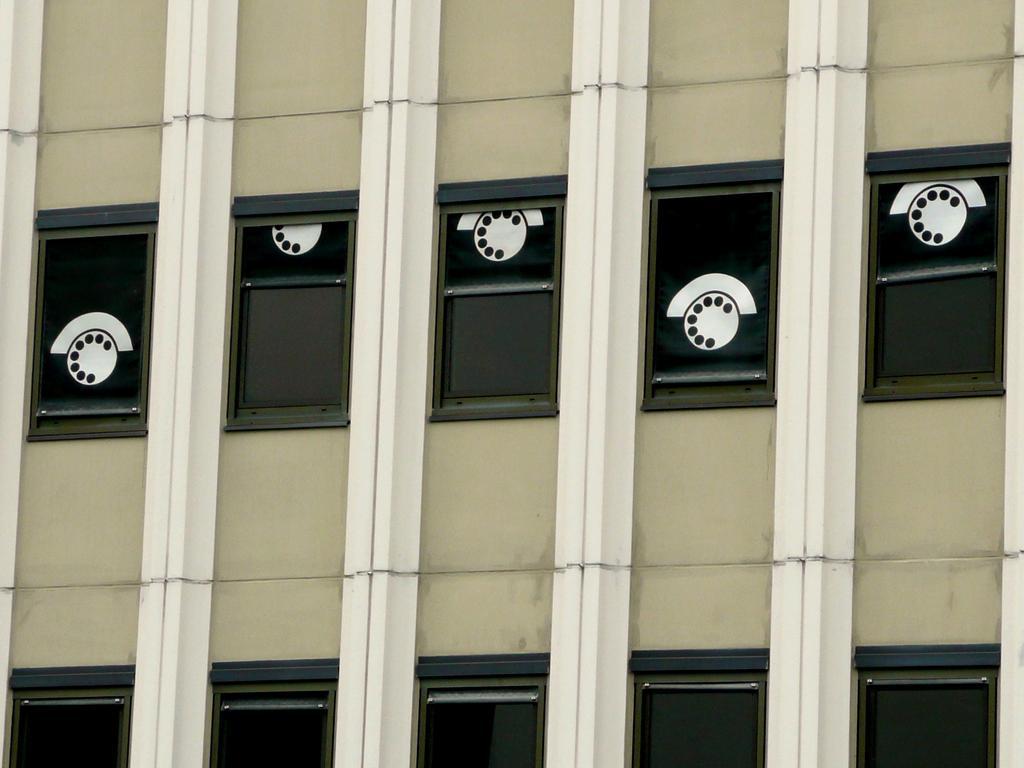Describe this image in one or two sentences. In this image we can see building on which there are some different pictures and building is in green color. 